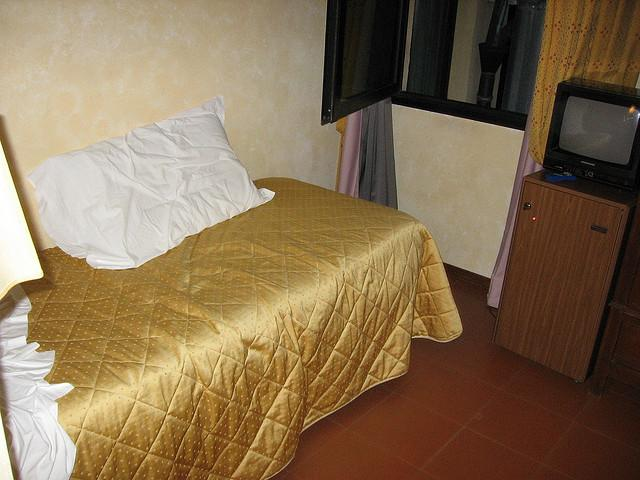What color is the sheet covering the small twin bed on the corner of the room? gold 